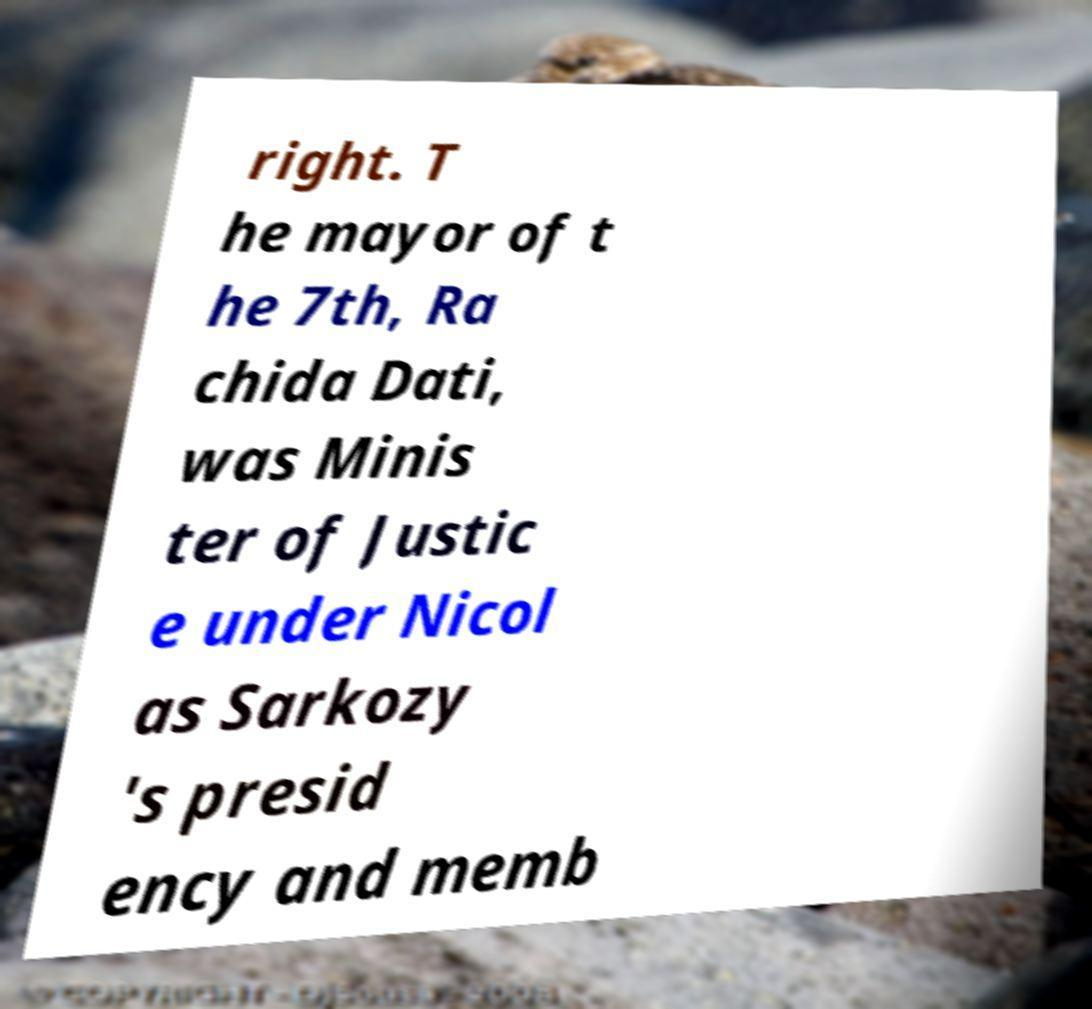Could you extract and type out the text from this image? right. T he mayor of t he 7th, Ra chida Dati, was Minis ter of Justic e under Nicol as Sarkozy 's presid ency and memb 